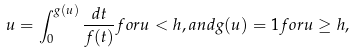<formula> <loc_0><loc_0><loc_500><loc_500>u = \int _ { 0 } ^ { g ( u ) } \frac { d t } { f ( t ) } f o r u < h , a n d g ( u ) = 1 f o r u \geq h ,</formula> 